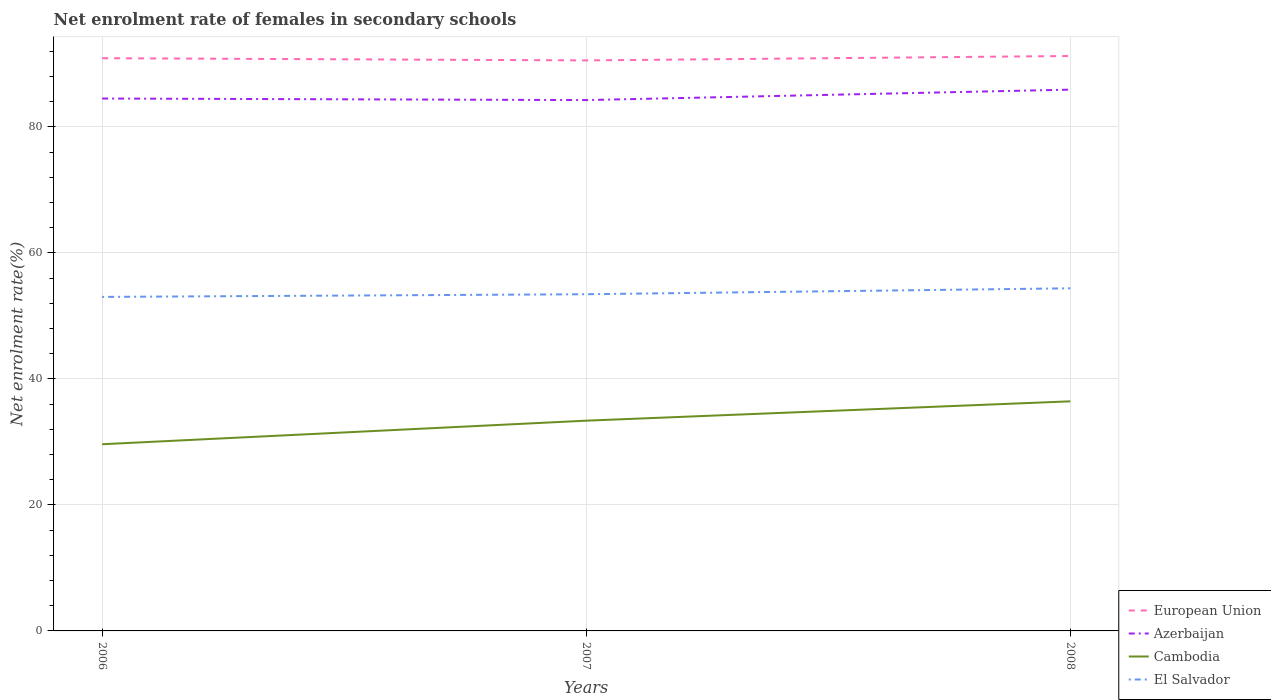Does the line corresponding to Azerbaijan intersect with the line corresponding to European Union?
Provide a succinct answer. No. Across all years, what is the maximum net enrolment rate of females in secondary schools in Azerbaijan?
Make the answer very short. 84.26. What is the total net enrolment rate of females in secondary schools in European Union in the graph?
Ensure brevity in your answer.  -0.35. What is the difference between the highest and the second highest net enrolment rate of females in secondary schools in El Salvador?
Give a very brief answer. 1.37. What is the difference between the highest and the lowest net enrolment rate of females in secondary schools in El Salvador?
Make the answer very short. 1. Is the net enrolment rate of females in secondary schools in Cambodia strictly greater than the net enrolment rate of females in secondary schools in European Union over the years?
Your answer should be compact. Yes. How many years are there in the graph?
Give a very brief answer. 3. What is the difference between two consecutive major ticks on the Y-axis?
Your answer should be compact. 20. Does the graph contain any zero values?
Offer a very short reply. No. Does the graph contain grids?
Keep it short and to the point. Yes. Where does the legend appear in the graph?
Make the answer very short. Bottom right. What is the title of the graph?
Offer a terse response. Net enrolment rate of females in secondary schools. Does "North America" appear as one of the legend labels in the graph?
Provide a short and direct response. No. What is the label or title of the Y-axis?
Your answer should be very brief. Net enrolment rate(%). What is the Net enrolment rate(%) of European Union in 2006?
Your answer should be compact. 90.91. What is the Net enrolment rate(%) of Azerbaijan in 2006?
Your answer should be very brief. 84.51. What is the Net enrolment rate(%) in Cambodia in 2006?
Your answer should be very brief. 29.63. What is the Net enrolment rate(%) of El Salvador in 2006?
Your answer should be compact. 53.02. What is the Net enrolment rate(%) of European Union in 2007?
Offer a terse response. 90.56. What is the Net enrolment rate(%) of Azerbaijan in 2007?
Give a very brief answer. 84.26. What is the Net enrolment rate(%) of Cambodia in 2007?
Offer a terse response. 33.37. What is the Net enrolment rate(%) of El Salvador in 2007?
Provide a succinct answer. 53.44. What is the Net enrolment rate(%) in European Union in 2008?
Your answer should be very brief. 91.26. What is the Net enrolment rate(%) in Azerbaijan in 2008?
Ensure brevity in your answer.  85.92. What is the Net enrolment rate(%) in Cambodia in 2008?
Your answer should be compact. 36.45. What is the Net enrolment rate(%) in El Salvador in 2008?
Offer a very short reply. 54.39. Across all years, what is the maximum Net enrolment rate(%) of European Union?
Keep it short and to the point. 91.26. Across all years, what is the maximum Net enrolment rate(%) in Azerbaijan?
Offer a terse response. 85.92. Across all years, what is the maximum Net enrolment rate(%) in Cambodia?
Your answer should be compact. 36.45. Across all years, what is the maximum Net enrolment rate(%) in El Salvador?
Provide a short and direct response. 54.39. Across all years, what is the minimum Net enrolment rate(%) in European Union?
Offer a terse response. 90.56. Across all years, what is the minimum Net enrolment rate(%) in Azerbaijan?
Your response must be concise. 84.26. Across all years, what is the minimum Net enrolment rate(%) of Cambodia?
Offer a very short reply. 29.63. Across all years, what is the minimum Net enrolment rate(%) of El Salvador?
Give a very brief answer. 53.02. What is the total Net enrolment rate(%) of European Union in the graph?
Offer a very short reply. 272.73. What is the total Net enrolment rate(%) in Azerbaijan in the graph?
Provide a succinct answer. 254.7. What is the total Net enrolment rate(%) in Cambodia in the graph?
Give a very brief answer. 99.45. What is the total Net enrolment rate(%) in El Salvador in the graph?
Provide a succinct answer. 160.85. What is the difference between the Net enrolment rate(%) of European Union in 2006 and that in 2007?
Provide a short and direct response. 0.35. What is the difference between the Net enrolment rate(%) in Azerbaijan in 2006 and that in 2007?
Offer a terse response. 0.25. What is the difference between the Net enrolment rate(%) of Cambodia in 2006 and that in 2007?
Offer a terse response. -3.74. What is the difference between the Net enrolment rate(%) of El Salvador in 2006 and that in 2007?
Your response must be concise. -0.42. What is the difference between the Net enrolment rate(%) of European Union in 2006 and that in 2008?
Your answer should be compact. -0.35. What is the difference between the Net enrolment rate(%) of Azerbaijan in 2006 and that in 2008?
Ensure brevity in your answer.  -1.41. What is the difference between the Net enrolment rate(%) in Cambodia in 2006 and that in 2008?
Offer a terse response. -6.81. What is the difference between the Net enrolment rate(%) in El Salvador in 2006 and that in 2008?
Provide a short and direct response. -1.37. What is the difference between the Net enrolment rate(%) in European Union in 2007 and that in 2008?
Offer a very short reply. -0.7. What is the difference between the Net enrolment rate(%) of Azerbaijan in 2007 and that in 2008?
Keep it short and to the point. -1.66. What is the difference between the Net enrolment rate(%) in Cambodia in 2007 and that in 2008?
Provide a short and direct response. -3.07. What is the difference between the Net enrolment rate(%) of El Salvador in 2007 and that in 2008?
Offer a terse response. -0.94. What is the difference between the Net enrolment rate(%) in European Union in 2006 and the Net enrolment rate(%) in Azerbaijan in 2007?
Make the answer very short. 6.65. What is the difference between the Net enrolment rate(%) in European Union in 2006 and the Net enrolment rate(%) in Cambodia in 2007?
Give a very brief answer. 57.54. What is the difference between the Net enrolment rate(%) in European Union in 2006 and the Net enrolment rate(%) in El Salvador in 2007?
Offer a terse response. 37.47. What is the difference between the Net enrolment rate(%) of Azerbaijan in 2006 and the Net enrolment rate(%) of Cambodia in 2007?
Your response must be concise. 51.14. What is the difference between the Net enrolment rate(%) of Azerbaijan in 2006 and the Net enrolment rate(%) of El Salvador in 2007?
Give a very brief answer. 31.07. What is the difference between the Net enrolment rate(%) of Cambodia in 2006 and the Net enrolment rate(%) of El Salvador in 2007?
Make the answer very short. -23.81. What is the difference between the Net enrolment rate(%) in European Union in 2006 and the Net enrolment rate(%) in Azerbaijan in 2008?
Offer a very short reply. 4.99. What is the difference between the Net enrolment rate(%) of European Union in 2006 and the Net enrolment rate(%) of Cambodia in 2008?
Keep it short and to the point. 54.47. What is the difference between the Net enrolment rate(%) of European Union in 2006 and the Net enrolment rate(%) of El Salvador in 2008?
Your answer should be very brief. 36.52. What is the difference between the Net enrolment rate(%) of Azerbaijan in 2006 and the Net enrolment rate(%) of Cambodia in 2008?
Provide a short and direct response. 48.07. What is the difference between the Net enrolment rate(%) in Azerbaijan in 2006 and the Net enrolment rate(%) in El Salvador in 2008?
Offer a terse response. 30.12. What is the difference between the Net enrolment rate(%) in Cambodia in 2006 and the Net enrolment rate(%) in El Salvador in 2008?
Give a very brief answer. -24.75. What is the difference between the Net enrolment rate(%) of European Union in 2007 and the Net enrolment rate(%) of Azerbaijan in 2008?
Provide a short and direct response. 4.64. What is the difference between the Net enrolment rate(%) in European Union in 2007 and the Net enrolment rate(%) in Cambodia in 2008?
Keep it short and to the point. 54.12. What is the difference between the Net enrolment rate(%) in European Union in 2007 and the Net enrolment rate(%) in El Salvador in 2008?
Offer a very short reply. 36.17. What is the difference between the Net enrolment rate(%) of Azerbaijan in 2007 and the Net enrolment rate(%) of Cambodia in 2008?
Offer a very short reply. 47.82. What is the difference between the Net enrolment rate(%) of Azerbaijan in 2007 and the Net enrolment rate(%) of El Salvador in 2008?
Provide a succinct answer. 29.88. What is the difference between the Net enrolment rate(%) of Cambodia in 2007 and the Net enrolment rate(%) of El Salvador in 2008?
Make the answer very short. -21.01. What is the average Net enrolment rate(%) of European Union per year?
Ensure brevity in your answer.  90.91. What is the average Net enrolment rate(%) of Azerbaijan per year?
Your answer should be very brief. 84.9. What is the average Net enrolment rate(%) in Cambodia per year?
Ensure brevity in your answer.  33.15. What is the average Net enrolment rate(%) of El Salvador per year?
Offer a terse response. 53.62. In the year 2006, what is the difference between the Net enrolment rate(%) in European Union and Net enrolment rate(%) in Azerbaijan?
Your answer should be very brief. 6.4. In the year 2006, what is the difference between the Net enrolment rate(%) of European Union and Net enrolment rate(%) of Cambodia?
Your answer should be compact. 61.28. In the year 2006, what is the difference between the Net enrolment rate(%) in European Union and Net enrolment rate(%) in El Salvador?
Offer a terse response. 37.89. In the year 2006, what is the difference between the Net enrolment rate(%) of Azerbaijan and Net enrolment rate(%) of Cambodia?
Your answer should be very brief. 54.88. In the year 2006, what is the difference between the Net enrolment rate(%) of Azerbaijan and Net enrolment rate(%) of El Salvador?
Make the answer very short. 31.49. In the year 2006, what is the difference between the Net enrolment rate(%) of Cambodia and Net enrolment rate(%) of El Salvador?
Give a very brief answer. -23.39. In the year 2007, what is the difference between the Net enrolment rate(%) of European Union and Net enrolment rate(%) of Azerbaijan?
Your response must be concise. 6.3. In the year 2007, what is the difference between the Net enrolment rate(%) in European Union and Net enrolment rate(%) in Cambodia?
Your answer should be compact. 57.19. In the year 2007, what is the difference between the Net enrolment rate(%) in European Union and Net enrolment rate(%) in El Salvador?
Your answer should be very brief. 37.12. In the year 2007, what is the difference between the Net enrolment rate(%) of Azerbaijan and Net enrolment rate(%) of Cambodia?
Offer a very short reply. 50.89. In the year 2007, what is the difference between the Net enrolment rate(%) of Azerbaijan and Net enrolment rate(%) of El Salvador?
Provide a succinct answer. 30.82. In the year 2007, what is the difference between the Net enrolment rate(%) in Cambodia and Net enrolment rate(%) in El Salvador?
Give a very brief answer. -20.07. In the year 2008, what is the difference between the Net enrolment rate(%) in European Union and Net enrolment rate(%) in Azerbaijan?
Ensure brevity in your answer.  5.34. In the year 2008, what is the difference between the Net enrolment rate(%) in European Union and Net enrolment rate(%) in Cambodia?
Keep it short and to the point. 54.82. In the year 2008, what is the difference between the Net enrolment rate(%) in European Union and Net enrolment rate(%) in El Salvador?
Ensure brevity in your answer.  36.88. In the year 2008, what is the difference between the Net enrolment rate(%) of Azerbaijan and Net enrolment rate(%) of Cambodia?
Keep it short and to the point. 49.48. In the year 2008, what is the difference between the Net enrolment rate(%) in Azerbaijan and Net enrolment rate(%) in El Salvador?
Offer a terse response. 31.54. In the year 2008, what is the difference between the Net enrolment rate(%) of Cambodia and Net enrolment rate(%) of El Salvador?
Make the answer very short. -17.94. What is the ratio of the Net enrolment rate(%) of Azerbaijan in 2006 to that in 2007?
Your answer should be compact. 1. What is the ratio of the Net enrolment rate(%) of Cambodia in 2006 to that in 2007?
Make the answer very short. 0.89. What is the ratio of the Net enrolment rate(%) of European Union in 2006 to that in 2008?
Your answer should be compact. 1. What is the ratio of the Net enrolment rate(%) of Azerbaijan in 2006 to that in 2008?
Offer a terse response. 0.98. What is the ratio of the Net enrolment rate(%) in Cambodia in 2006 to that in 2008?
Your response must be concise. 0.81. What is the ratio of the Net enrolment rate(%) of El Salvador in 2006 to that in 2008?
Make the answer very short. 0.97. What is the ratio of the Net enrolment rate(%) of Azerbaijan in 2007 to that in 2008?
Keep it short and to the point. 0.98. What is the ratio of the Net enrolment rate(%) in Cambodia in 2007 to that in 2008?
Provide a succinct answer. 0.92. What is the ratio of the Net enrolment rate(%) in El Salvador in 2007 to that in 2008?
Offer a terse response. 0.98. What is the difference between the highest and the second highest Net enrolment rate(%) in European Union?
Provide a short and direct response. 0.35. What is the difference between the highest and the second highest Net enrolment rate(%) in Azerbaijan?
Make the answer very short. 1.41. What is the difference between the highest and the second highest Net enrolment rate(%) of Cambodia?
Ensure brevity in your answer.  3.07. What is the difference between the highest and the second highest Net enrolment rate(%) in El Salvador?
Your response must be concise. 0.94. What is the difference between the highest and the lowest Net enrolment rate(%) of European Union?
Give a very brief answer. 0.7. What is the difference between the highest and the lowest Net enrolment rate(%) in Azerbaijan?
Your answer should be very brief. 1.66. What is the difference between the highest and the lowest Net enrolment rate(%) of Cambodia?
Keep it short and to the point. 6.81. What is the difference between the highest and the lowest Net enrolment rate(%) of El Salvador?
Your answer should be compact. 1.37. 